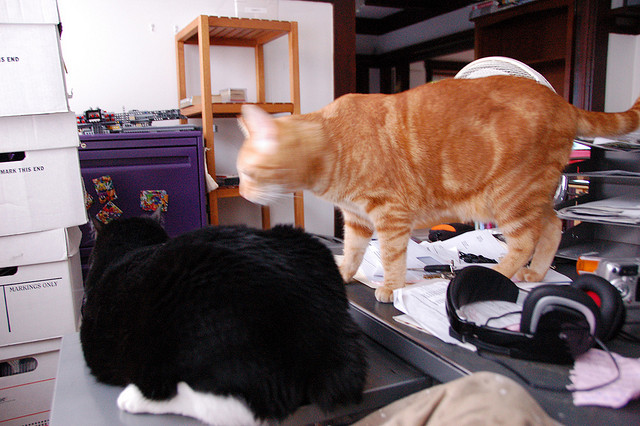Please transcribe the text in this image. S MARK IND 